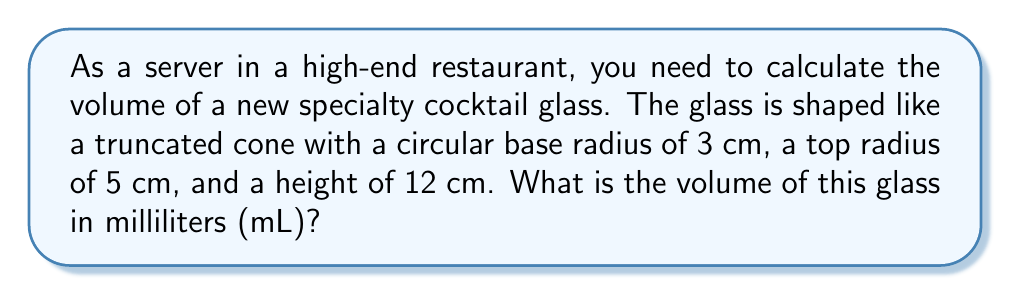Solve this math problem. To solve this problem, we'll use the formula for the volume of a truncated cone and convert the result to milliliters. Here's the step-by-step solution:

1. The formula for the volume of a truncated cone is:
   $$V = \frac{1}{3}\pi h(R^2 + r^2 + Rr)$$
   where $V$ is volume, $h$ is height, $R$ is the radius of the larger circle, and $r$ is the radius of the smaller circle.

2. We have the following values:
   $h = 12$ cm
   $R = 5$ cm (top radius)
   $r = 3$ cm (base radius)

3. Let's substitute these values into the formula:
   $$V = \frac{1}{3}\pi \cdot 12(5^2 + 3^2 + 5 \cdot 3)$$

4. Simplify the expression inside the parentheses:
   $$V = \frac{1}{3}\pi \cdot 12(25 + 9 + 15)$$
   $$V = \frac{1}{3}\pi \cdot 12(49)$$

5. Multiply the numbers:
   $$V = 4\pi \cdot 49 = 196\pi$$

6. Calculate the approximate value (π ≈ 3.14159):
   $$V \approx 196 \cdot 3.14159 \approx 615.75174 \text{ cm}^3$$

7. Convert cubic centimeters to milliliters (1 cm³ = 1 mL):
   $$615.75174 \text{ cm}^3 = 615.75174 \text{ mL}$$

8. Round to the nearest milliliter:
   $$615.75174 \text{ mL} \approx 616 \text{ mL}$$
Answer: 616 mL 